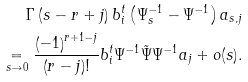Convert formula to latex. <formula><loc_0><loc_0><loc_500><loc_500>\Gamma \left ( s - r + j \right ) b _ { i } ^ { t } \left ( \Psi _ { s } ^ { - 1 } - \Psi ^ { - 1 } \right ) a _ { s , j } \\ \underset { s \to 0 } { = } \frac { \left ( - 1 \right ) ^ { r + 1 - j } } { \left ( r - j \right ) ! } b _ { i } ^ { t } \Psi ^ { - 1 } \tilde { \Psi } \Psi ^ { - 1 } a _ { j } + o ( s ) .</formula> 